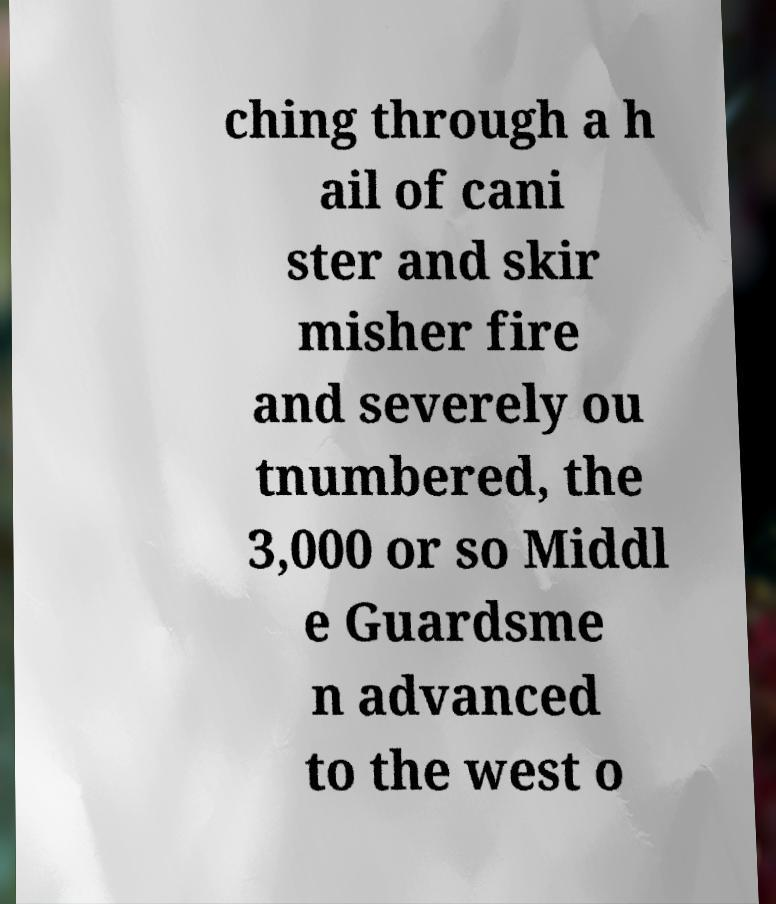Could you extract and type out the text from this image? ching through a h ail of cani ster and skir misher fire and severely ou tnumbered, the 3,000 or so Middl e Guardsme n advanced to the west o 